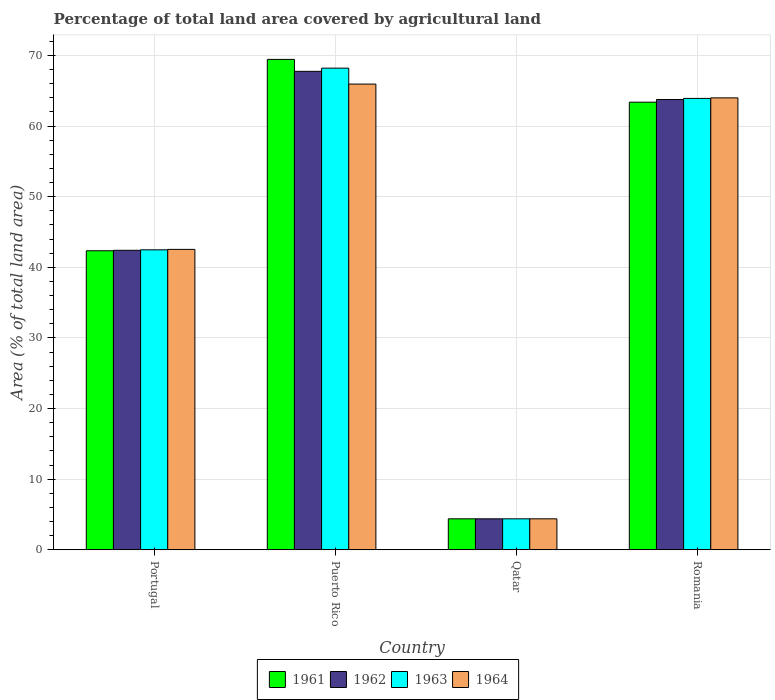How many groups of bars are there?
Give a very brief answer. 4. Are the number of bars per tick equal to the number of legend labels?
Offer a very short reply. Yes. How many bars are there on the 2nd tick from the left?
Make the answer very short. 4. What is the label of the 3rd group of bars from the left?
Provide a succinct answer. Qatar. In how many cases, is the number of bars for a given country not equal to the number of legend labels?
Make the answer very short. 0. What is the percentage of agricultural land in 1964 in Portugal?
Offer a terse response. 42.55. Across all countries, what is the maximum percentage of agricultural land in 1961?
Your answer should be compact. 69.45. Across all countries, what is the minimum percentage of agricultural land in 1963?
Offer a terse response. 4.39. In which country was the percentage of agricultural land in 1961 maximum?
Offer a very short reply. Puerto Rico. In which country was the percentage of agricultural land in 1962 minimum?
Your response must be concise. Qatar. What is the total percentage of agricultural land in 1961 in the graph?
Make the answer very short. 179.58. What is the difference between the percentage of agricultural land in 1961 in Puerto Rico and that in Qatar?
Your answer should be compact. 65.05. What is the difference between the percentage of agricultural land in 1963 in Romania and the percentage of agricultural land in 1962 in Portugal?
Give a very brief answer. 21.51. What is the average percentage of agricultural land in 1964 per country?
Your response must be concise. 44.22. What is the difference between the percentage of agricultural land of/in 1964 and percentage of agricultural land of/in 1963 in Romania?
Ensure brevity in your answer.  0.08. What is the ratio of the percentage of agricultural land in 1962 in Puerto Rico to that in Qatar?
Provide a succinct answer. 15.42. Is the difference between the percentage of agricultural land in 1964 in Qatar and Romania greater than the difference between the percentage of agricultural land in 1963 in Qatar and Romania?
Offer a very short reply. No. What is the difference between the highest and the second highest percentage of agricultural land in 1963?
Provide a short and direct response. -25.73. What is the difference between the highest and the lowest percentage of agricultural land in 1963?
Keep it short and to the point. 63.81. Is the sum of the percentage of agricultural land in 1963 in Qatar and Romania greater than the maximum percentage of agricultural land in 1962 across all countries?
Offer a very short reply. Yes. Is it the case that in every country, the sum of the percentage of agricultural land in 1961 and percentage of agricultural land in 1964 is greater than the sum of percentage of agricultural land in 1963 and percentage of agricultural land in 1962?
Keep it short and to the point. No. What does the 2nd bar from the right in Portugal represents?
Your answer should be compact. 1963. Does the graph contain grids?
Provide a short and direct response. Yes. How many legend labels are there?
Keep it short and to the point. 4. How are the legend labels stacked?
Your answer should be very brief. Horizontal. What is the title of the graph?
Your response must be concise. Percentage of total land area covered by agricultural land. What is the label or title of the X-axis?
Your answer should be compact. Country. What is the label or title of the Y-axis?
Your answer should be very brief. Area (% of total land area). What is the Area (% of total land area) of 1961 in Portugal?
Ensure brevity in your answer.  42.35. What is the Area (% of total land area) of 1962 in Portugal?
Provide a succinct answer. 42.42. What is the Area (% of total land area) of 1963 in Portugal?
Keep it short and to the point. 42.48. What is the Area (% of total land area) in 1964 in Portugal?
Keep it short and to the point. 42.55. What is the Area (% of total land area) in 1961 in Puerto Rico?
Keep it short and to the point. 69.45. What is the Area (% of total land area) of 1962 in Puerto Rico?
Keep it short and to the point. 67.76. What is the Area (% of total land area) of 1963 in Puerto Rico?
Your answer should be compact. 68.21. What is the Area (% of total land area) of 1964 in Puerto Rico?
Make the answer very short. 65.95. What is the Area (% of total land area) of 1961 in Qatar?
Give a very brief answer. 4.39. What is the Area (% of total land area) of 1962 in Qatar?
Provide a succinct answer. 4.39. What is the Area (% of total land area) of 1963 in Qatar?
Provide a short and direct response. 4.39. What is the Area (% of total land area) of 1964 in Qatar?
Make the answer very short. 4.39. What is the Area (% of total land area) in 1961 in Romania?
Offer a terse response. 63.39. What is the Area (% of total land area) in 1962 in Romania?
Offer a very short reply. 63.77. What is the Area (% of total land area) of 1963 in Romania?
Your response must be concise. 63.92. What is the Area (% of total land area) of 1964 in Romania?
Keep it short and to the point. 64. Across all countries, what is the maximum Area (% of total land area) of 1961?
Offer a terse response. 69.45. Across all countries, what is the maximum Area (% of total land area) in 1962?
Your answer should be compact. 67.76. Across all countries, what is the maximum Area (% of total land area) of 1963?
Offer a very short reply. 68.21. Across all countries, what is the maximum Area (% of total land area) in 1964?
Your answer should be compact. 65.95. Across all countries, what is the minimum Area (% of total land area) in 1961?
Your response must be concise. 4.39. Across all countries, what is the minimum Area (% of total land area) in 1962?
Make the answer very short. 4.39. Across all countries, what is the minimum Area (% of total land area) in 1963?
Your answer should be very brief. 4.39. Across all countries, what is the minimum Area (% of total land area) of 1964?
Your answer should be very brief. 4.39. What is the total Area (% of total land area) in 1961 in the graph?
Your response must be concise. 179.58. What is the total Area (% of total land area) of 1962 in the graph?
Your response must be concise. 178.33. What is the total Area (% of total land area) of 1963 in the graph?
Provide a short and direct response. 179. What is the total Area (% of total land area) of 1964 in the graph?
Offer a very short reply. 176.89. What is the difference between the Area (% of total land area) in 1961 in Portugal and that in Puerto Rico?
Keep it short and to the point. -27.1. What is the difference between the Area (% of total land area) in 1962 in Portugal and that in Puerto Rico?
Ensure brevity in your answer.  -25.34. What is the difference between the Area (% of total land area) of 1963 in Portugal and that in Puerto Rico?
Provide a short and direct response. -25.73. What is the difference between the Area (% of total land area) of 1964 in Portugal and that in Puerto Rico?
Keep it short and to the point. -23.41. What is the difference between the Area (% of total land area) in 1961 in Portugal and that in Qatar?
Provide a succinct answer. 37.96. What is the difference between the Area (% of total land area) of 1962 in Portugal and that in Qatar?
Your answer should be very brief. 38.02. What is the difference between the Area (% of total land area) of 1963 in Portugal and that in Qatar?
Ensure brevity in your answer.  38.09. What is the difference between the Area (% of total land area) in 1964 in Portugal and that in Qatar?
Your response must be concise. 38.15. What is the difference between the Area (% of total land area) in 1961 in Portugal and that in Romania?
Offer a very short reply. -21.04. What is the difference between the Area (% of total land area) in 1962 in Portugal and that in Romania?
Make the answer very short. -21.35. What is the difference between the Area (% of total land area) of 1963 in Portugal and that in Romania?
Give a very brief answer. -21.44. What is the difference between the Area (% of total land area) in 1964 in Portugal and that in Romania?
Your answer should be very brief. -21.45. What is the difference between the Area (% of total land area) of 1961 in Puerto Rico and that in Qatar?
Your response must be concise. 65.05. What is the difference between the Area (% of total land area) in 1962 in Puerto Rico and that in Qatar?
Provide a succinct answer. 63.36. What is the difference between the Area (% of total land area) in 1963 in Puerto Rico and that in Qatar?
Your answer should be very brief. 63.81. What is the difference between the Area (% of total land area) in 1964 in Puerto Rico and that in Qatar?
Your answer should be compact. 61.56. What is the difference between the Area (% of total land area) of 1961 in Puerto Rico and that in Romania?
Keep it short and to the point. 6.06. What is the difference between the Area (% of total land area) of 1962 in Puerto Rico and that in Romania?
Provide a short and direct response. 3.99. What is the difference between the Area (% of total land area) of 1963 in Puerto Rico and that in Romania?
Make the answer very short. 4.28. What is the difference between the Area (% of total land area) in 1964 in Puerto Rico and that in Romania?
Give a very brief answer. 1.95. What is the difference between the Area (% of total land area) in 1961 in Qatar and that in Romania?
Make the answer very short. -59. What is the difference between the Area (% of total land area) in 1962 in Qatar and that in Romania?
Provide a short and direct response. -59.37. What is the difference between the Area (% of total land area) in 1963 in Qatar and that in Romania?
Offer a very short reply. -59.53. What is the difference between the Area (% of total land area) in 1964 in Qatar and that in Romania?
Your answer should be very brief. -59.61. What is the difference between the Area (% of total land area) of 1961 in Portugal and the Area (% of total land area) of 1962 in Puerto Rico?
Your response must be concise. -25.41. What is the difference between the Area (% of total land area) in 1961 in Portugal and the Area (% of total land area) in 1963 in Puerto Rico?
Provide a succinct answer. -25.86. What is the difference between the Area (% of total land area) of 1961 in Portugal and the Area (% of total land area) of 1964 in Puerto Rico?
Provide a short and direct response. -23.6. What is the difference between the Area (% of total land area) in 1962 in Portugal and the Area (% of total land area) in 1963 in Puerto Rico?
Make the answer very short. -25.79. What is the difference between the Area (% of total land area) of 1962 in Portugal and the Area (% of total land area) of 1964 in Puerto Rico?
Give a very brief answer. -23.54. What is the difference between the Area (% of total land area) in 1963 in Portugal and the Area (% of total land area) in 1964 in Puerto Rico?
Give a very brief answer. -23.47. What is the difference between the Area (% of total land area) of 1961 in Portugal and the Area (% of total land area) of 1962 in Qatar?
Offer a terse response. 37.96. What is the difference between the Area (% of total land area) in 1961 in Portugal and the Area (% of total land area) in 1963 in Qatar?
Provide a succinct answer. 37.96. What is the difference between the Area (% of total land area) in 1961 in Portugal and the Area (% of total land area) in 1964 in Qatar?
Ensure brevity in your answer.  37.96. What is the difference between the Area (% of total land area) in 1962 in Portugal and the Area (% of total land area) in 1963 in Qatar?
Your answer should be very brief. 38.02. What is the difference between the Area (% of total land area) in 1962 in Portugal and the Area (% of total land area) in 1964 in Qatar?
Ensure brevity in your answer.  38.02. What is the difference between the Area (% of total land area) in 1963 in Portugal and the Area (% of total land area) in 1964 in Qatar?
Provide a short and direct response. 38.09. What is the difference between the Area (% of total land area) of 1961 in Portugal and the Area (% of total land area) of 1962 in Romania?
Ensure brevity in your answer.  -21.42. What is the difference between the Area (% of total land area) of 1961 in Portugal and the Area (% of total land area) of 1963 in Romania?
Offer a very short reply. -21.57. What is the difference between the Area (% of total land area) of 1961 in Portugal and the Area (% of total land area) of 1964 in Romania?
Provide a succinct answer. -21.65. What is the difference between the Area (% of total land area) in 1962 in Portugal and the Area (% of total land area) in 1963 in Romania?
Your answer should be compact. -21.51. What is the difference between the Area (% of total land area) in 1962 in Portugal and the Area (% of total land area) in 1964 in Romania?
Make the answer very short. -21.59. What is the difference between the Area (% of total land area) in 1963 in Portugal and the Area (% of total land area) in 1964 in Romania?
Keep it short and to the point. -21.52. What is the difference between the Area (% of total land area) of 1961 in Puerto Rico and the Area (% of total land area) of 1962 in Qatar?
Provide a short and direct response. 65.05. What is the difference between the Area (% of total land area) of 1961 in Puerto Rico and the Area (% of total land area) of 1963 in Qatar?
Keep it short and to the point. 65.05. What is the difference between the Area (% of total land area) of 1961 in Puerto Rico and the Area (% of total land area) of 1964 in Qatar?
Provide a succinct answer. 65.05. What is the difference between the Area (% of total land area) of 1962 in Puerto Rico and the Area (% of total land area) of 1963 in Qatar?
Provide a succinct answer. 63.36. What is the difference between the Area (% of total land area) of 1962 in Puerto Rico and the Area (% of total land area) of 1964 in Qatar?
Your answer should be compact. 63.36. What is the difference between the Area (% of total land area) of 1963 in Puerto Rico and the Area (% of total land area) of 1964 in Qatar?
Ensure brevity in your answer.  63.81. What is the difference between the Area (% of total land area) in 1961 in Puerto Rico and the Area (% of total land area) in 1962 in Romania?
Make the answer very short. 5.68. What is the difference between the Area (% of total land area) of 1961 in Puerto Rico and the Area (% of total land area) of 1963 in Romania?
Your response must be concise. 5.52. What is the difference between the Area (% of total land area) of 1961 in Puerto Rico and the Area (% of total land area) of 1964 in Romania?
Your response must be concise. 5.45. What is the difference between the Area (% of total land area) in 1962 in Puerto Rico and the Area (% of total land area) in 1963 in Romania?
Offer a very short reply. 3.83. What is the difference between the Area (% of total land area) in 1962 in Puerto Rico and the Area (% of total land area) in 1964 in Romania?
Provide a succinct answer. 3.76. What is the difference between the Area (% of total land area) of 1963 in Puerto Rico and the Area (% of total land area) of 1964 in Romania?
Make the answer very short. 4.21. What is the difference between the Area (% of total land area) in 1961 in Qatar and the Area (% of total land area) in 1962 in Romania?
Make the answer very short. -59.37. What is the difference between the Area (% of total land area) in 1961 in Qatar and the Area (% of total land area) in 1963 in Romania?
Give a very brief answer. -59.53. What is the difference between the Area (% of total land area) in 1961 in Qatar and the Area (% of total land area) in 1964 in Romania?
Make the answer very short. -59.61. What is the difference between the Area (% of total land area) of 1962 in Qatar and the Area (% of total land area) of 1963 in Romania?
Ensure brevity in your answer.  -59.53. What is the difference between the Area (% of total land area) in 1962 in Qatar and the Area (% of total land area) in 1964 in Romania?
Provide a short and direct response. -59.61. What is the difference between the Area (% of total land area) of 1963 in Qatar and the Area (% of total land area) of 1964 in Romania?
Offer a very short reply. -59.61. What is the average Area (% of total land area) of 1961 per country?
Ensure brevity in your answer.  44.89. What is the average Area (% of total land area) in 1962 per country?
Provide a short and direct response. 44.58. What is the average Area (% of total land area) in 1963 per country?
Provide a short and direct response. 44.75. What is the average Area (% of total land area) in 1964 per country?
Offer a terse response. 44.22. What is the difference between the Area (% of total land area) of 1961 and Area (% of total land area) of 1962 in Portugal?
Make the answer very short. -0.07. What is the difference between the Area (% of total land area) in 1961 and Area (% of total land area) in 1963 in Portugal?
Ensure brevity in your answer.  -0.13. What is the difference between the Area (% of total land area) in 1961 and Area (% of total land area) in 1964 in Portugal?
Offer a very short reply. -0.2. What is the difference between the Area (% of total land area) of 1962 and Area (% of total land area) of 1963 in Portugal?
Your response must be concise. -0.07. What is the difference between the Area (% of total land area) in 1962 and Area (% of total land area) in 1964 in Portugal?
Your answer should be very brief. -0.13. What is the difference between the Area (% of total land area) in 1963 and Area (% of total land area) in 1964 in Portugal?
Your response must be concise. -0.07. What is the difference between the Area (% of total land area) of 1961 and Area (% of total land area) of 1962 in Puerto Rico?
Your response must be concise. 1.69. What is the difference between the Area (% of total land area) in 1961 and Area (% of total land area) in 1963 in Puerto Rico?
Give a very brief answer. 1.24. What is the difference between the Area (% of total land area) in 1961 and Area (% of total land area) in 1964 in Puerto Rico?
Offer a terse response. 3.49. What is the difference between the Area (% of total land area) of 1962 and Area (% of total land area) of 1963 in Puerto Rico?
Offer a very short reply. -0.45. What is the difference between the Area (% of total land area) in 1962 and Area (% of total land area) in 1964 in Puerto Rico?
Ensure brevity in your answer.  1.8. What is the difference between the Area (% of total land area) in 1963 and Area (% of total land area) in 1964 in Puerto Rico?
Give a very brief answer. 2.25. What is the difference between the Area (% of total land area) in 1962 and Area (% of total land area) in 1963 in Qatar?
Offer a very short reply. 0. What is the difference between the Area (% of total land area) in 1963 and Area (% of total land area) in 1964 in Qatar?
Give a very brief answer. 0. What is the difference between the Area (% of total land area) of 1961 and Area (% of total land area) of 1962 in Romania?
Ensure brevity in your answer.  -0.38. What is the difference between the Area (% of total land area) of 1961 and Area (% of total land area) of 1963 in Romania?
Provide a short and direct response. -0.53. What is the difference between the Area (% of total land area) in 1961 and Area (% of total land area) in 1964 in Romania?
Offer a very short reply. -0.61. What is the difference between the Area (% of total land area) in 1962 and Area (% of total land area) in 1963 in Romania?
Keep it short and to the point. -0.16. What is the difference between the Area (% of total land area) in 1962 and Area (% of total land area) in 1964 in Romania?
Your answer should be very brief. -0.23. What is the difference between the Area (% of total land area) in 1963 and Area (% of total land area) in 1964 in Romania?
Provide a short and direct response. -0.08. What is the ratio of the Area (% of total land area) in 1961 in Portugal to that in Puerto Rico?
Your answer should be compact. 0.61. What is the ratio of the Area (% of total land area) of 1962 in Portugal to that in Puerto Rico?
Make the answer very short. 0.63. What is the ratio of the Area (% of total land area) of 1963 in Portugal to that in Puerto Rico?
Make the answer very short. 0.62. What is the ratio of the Area (% of total land area) of 1964 in Portugal to that in Puerto Rico?
Your answer should be compact. 0.65. What is the ratio of the Area (% of total land area) of 1961 in Portugal to that in Qatar?
Ensure brevity in your answer.  9.64. What is the ratio of the Area (% of total land area) in 1962 in Portugal to that in Qatar?
Your answer should be very brief. 9.66. What is the ratio of the Area (% of total land area) of 1963 in Portugal to that in Qatar?
Provide a short and direct response. 9.67. What is the ratio of the Area (% of total land area) of 1964 in Portugal to that in Qatar?
Make the answer very short. 9.69. What is the ratio of the Area (% of total land area) in 1961 in Portugal to that in Romania?
Give a very brief answer. 0.67. What is the ratio of the Area (% of total land area) of 1962 in Portugal to that in Romania?
Your answer should be compact. 0.67. What is the ratio of the Area (% of total land area) in 1963 in Portugal to that in Romania?
Your answer should be compact. 0.66. What is the ratio of the Area (% of total land area) of 1964 in Portugal to that in Romania?
Your response must be concise. 0.66. What is the ratio of the Area (% of total land area) of 1961 in Puerto Rico to that in Qatar?
Offer a very short reply. 15.81. What is the ratio of the Area (% of total land area) in 1962 in Puerto Rico to that in Qatar?
Ensure brevity in your answer.  15.42. What is the ratio of the Area (% of total land area) of 1963 in Puerto Rico to that in Qatar?
Your answer should be compact. 15.53. What is the ratio of the Area (% of total land area) in 1964 in Puerto Rico to that in Qatar?
Ensure brevity in your answer.  15.01. What is the ratio of the Area (% of total land area) of 1961 in Puerto Rico to that in Romania?
Offer a terse response. 1.1. What is the ratio of the Area (% of total land area) in 1962 in Puerto Rico to that in Romania?
Offer a very short reply. 1.06. What is the ratio of the Area (% of total land area) in 1963 in Puerto Rico to that in Romania?
Provide a short and direct response. 1.07. What is the ratio of the Area (% of total land area) of 1964 in Puerto Rico to that in Romania?
Keep it short and to the point. 1.03. What is the ratio of the Area (% of total land area) of 1961 in Qatar to that in Romania?
Offer a very short reply. 0.07. What is the ratio of the Area (% of total land area) of 1962 in Qatar to that in Romania?
Offer a very short reply. 0.07. What is the ratio of the Area (% of total land area) in 1963 in Qatar to that in Romania?
Your answer should be very brief. 0.07. What is the ratio of the Area (% of total land area) of 1964 in Qatar to that in Romania?
Offer a terse response. 0.07. What is the difference between the highest and the second highest Area (% of total land area) in 1961?
Ensure brevity in your answer.  6.06. What is the difference between the highest and the second highest Area (% of total land area) in 1962?
Provide a succinct answer. 3.99. What is the difference between the highest and the second highest Area (% of total land area) in 1963?
Offer a very short reply. 4.28. What is the difference between the highest and the second highest Area (% of total land area) of 1964?
Your response must be concise. 1.95. What is the difference between the highest and the lowest Area (% of total land area) of 1961?
Provide a short and direct response. 65.05. What is the difference between the highest and the lowest Area (% of total land area) of 1962?
Give a very brief answer. 63.36. What is the difference between the highest and the lowest Area (% of total land area) of 1963?
Offer a terse response. 63.81. What is the difference between the highest and the lowest Area (% of total land area) of 1964?
Offer a very short reply. 61.56. 